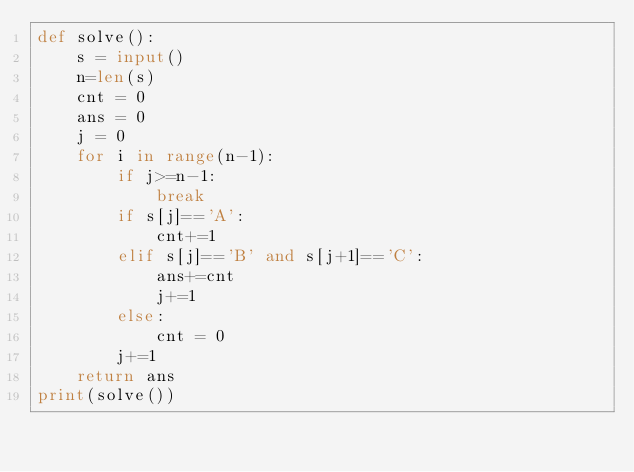Convert code to text. <code><loc_0><loc_0><loc_500><loc_500><_Python_>def solve():
    s = input()
    n=len(s)
    cnt = 0
    ans = 0
    j = 0
    for i in range(n-1):
        if j>=n-1:
            break
        if s[j]=='A':
            cnt+=1
        elif s[j]=='B' and s[j+1]=='C':
            ans+=cnt
            j+=1
        else:
            cnt = 0
        j+=1
    return ans
print(solve())</code> 